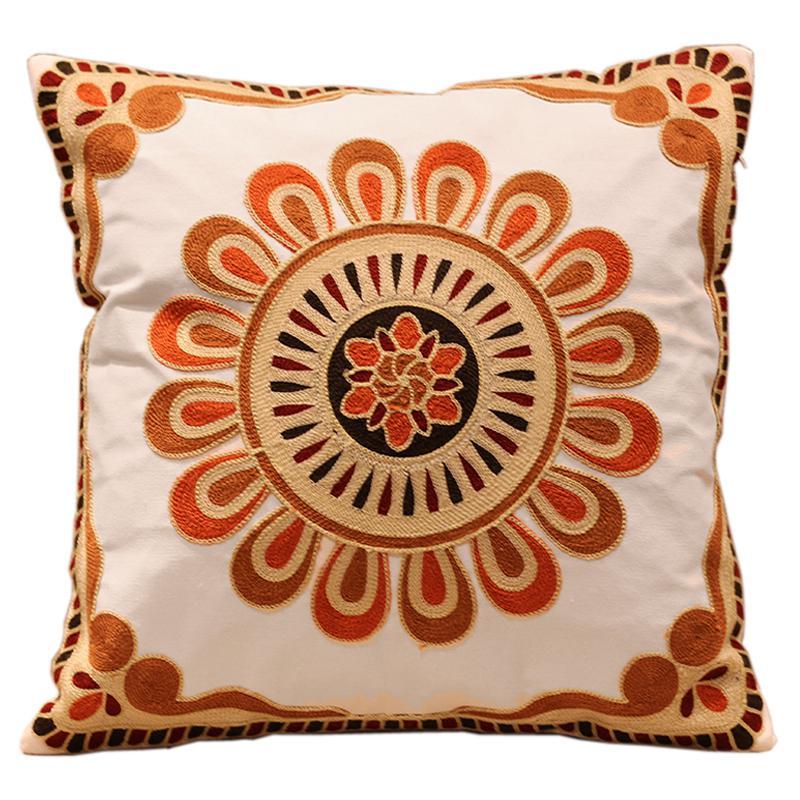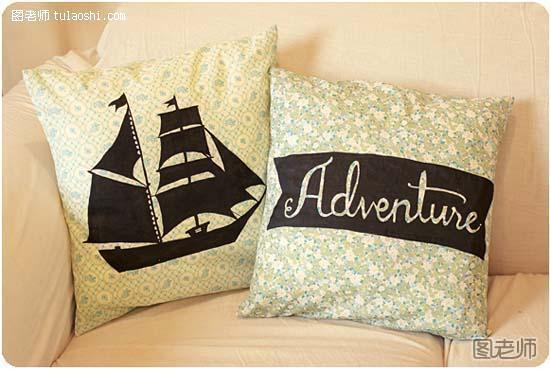The first image is the image on the left, the second image is the image on the right. Assess this claim about the two images: "One of the images has at least part of its pillow decoration written mostly in black ink.". Correct or not? Answer yes or no. Yes. The first image is the image on the left, the second image is the image on the right. Examine the images to the left and right. Is the description "There are at least 2 pillows in the right image." accurate? Answer yes or no. Yes. 